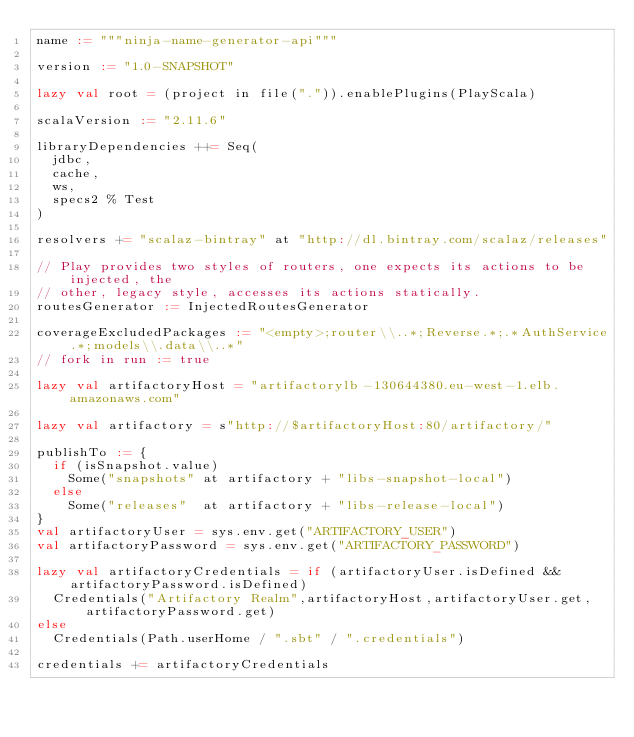<code> <loc_0><loc_0><loc_500><loc_500><_Scala_>name := """ninja-name-generator-api"""

version := "1.0-SNAPSHOT"

lazy val root = (project in file(".")).enablePlugins(PlayScala)

scalaVersion := "2.11.6"

libraryDependencies ++= Seq(
  jdbc,
  cache,
  ws,
  specs2 % Test
)

resolvers += "scalaz-bintray" at "http://dl.bintray.com/scalaz/releases"

// Play provides two styles of routers, one expects its actions to be injected, the
// other, legacy style, accesses its actions statically.
routesGenerator := InjectedRoutesGenerator

coverageExcludedPackages := "<empty>;router\\..*;Reverse.*;.*AuthService.*;models\\.data\\..*"
// fork in run := true

lazy val artifactoryHost = "artifactorylb-130644380.eu-west-1.elb.amazonaws.com"

lazy val artifactory = s"http://$artifactoryHost:80/artifactory/"

publishTo := {
  if (isSnapshot.value)
    Some("snapshots" at artifactory + "libs-snapshot-local")
  else
    Some("releases"  at artifactory + "libs-release-local")
}
val artifactoryUser = sys.env.get("ARTIFACTORY_USER")
val artifactoryPassword = sys.env.get("ARTIFACTORY_PASSWORD")

lazy val artifactoryCredentials = if (artifactoryUser.isDefined && artifactoryPassword.isDefined)
  Credentials("Artifactory Realm",artifactoryHost,artifactoryUser.get,artifactoryPassword.get)
else
  Credentials(Path.userHome / ".sbt" / ".credentials")

credentials += artifactoryCredentials
</code> 